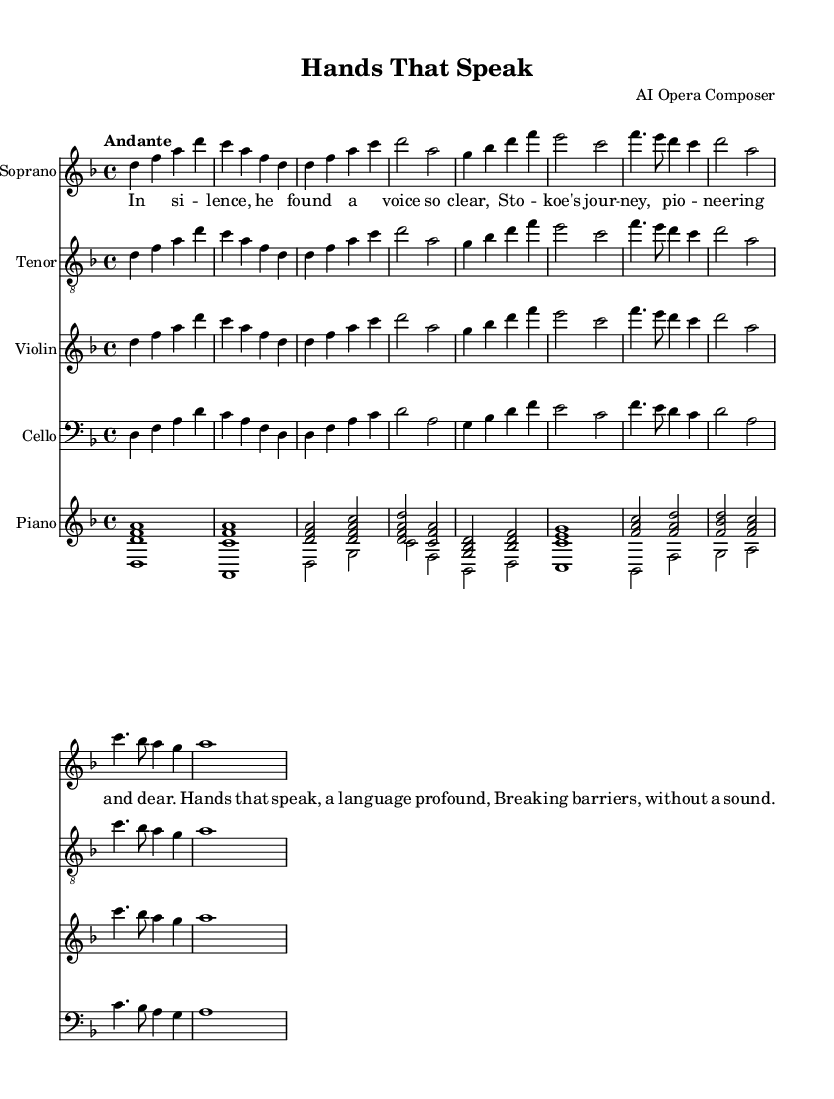What is the key signature of this music? The key signature is indicated at the beginning of the staff. In this music, it shows two flats, which correspond to the key of D minor.
Answer: D minor What is the time signature of this music? The time signature is indicated right after the key signature at the beginning of the score. It shows a "4/4," meaning there are four beats per measure and the quarter note gets one beat.
Answer: 4/4 What is the tempo marking in the score? The tempo marking is located at the beginning of the music, just below the time signature. It describes the speed of the piece and in this case, it is "Andante," which suggests a moderate pace.
Answer: Andante How many instruments are included in this score? By counting the staves written in the score, we see there are four staves for the soprano, tenor, violin, and cello, plus an additional piano staff, totaling five instruments.
Answer: Five What is the name of the piece? The title of the opera is clearly shown in the header section of the score sheet, which is "Hands That Speak."
Answer: Hands That Speak What is the theme of the lyrics? The lyrics convey a message about silence and finding one's voice, particularly referring to Stokoe's influence in sign language, which breaks barriers of communication without sound. The theme is about empowerment and connection through the act of signing.
Answer: Empowerment through sign language 